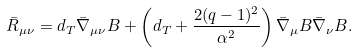Convert formula to latex. <formula><loc_0><loc_0><loc_500><loc_500>\bar { R } _ { \mu \nu } = d _ { T } \bar { \nabla } _ { \mu \nu } B + \left ( d _ { T } + \frac { 2 ( q - 1 ) ^ { 2 } } { \alpha ^ { 2 } } \right ) \bar { \nabla } _ { \mu } B \bar { \nabla } _ { \nu } B .</formula> 